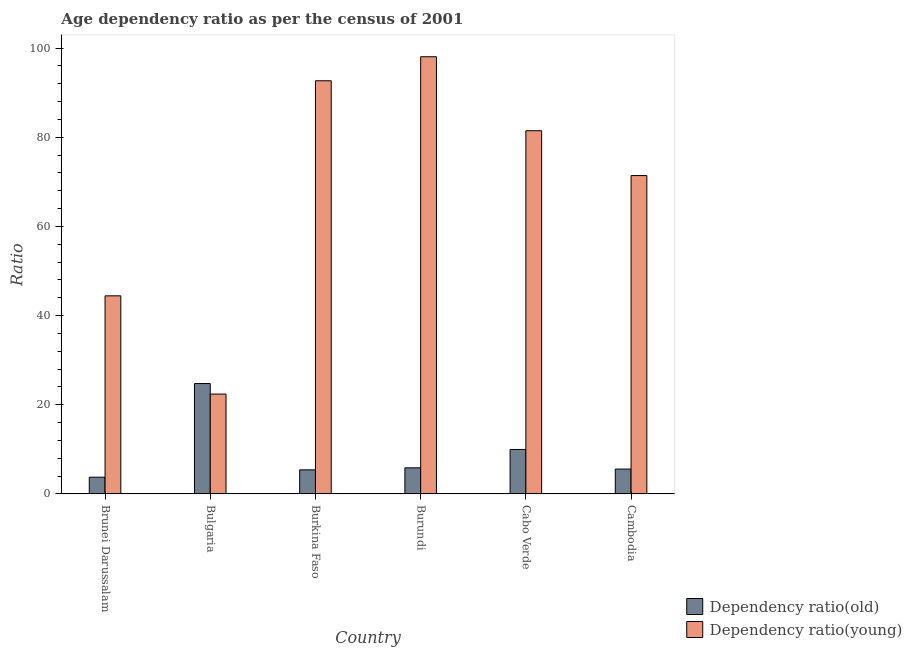How many bars are there on the 2nd tick from the left?
Your answer should be compact. 2. What is the label of the 2nd group of bars from the left?
Keep it short and to the point. Bulgaria. In how many cases, is the number of bars for a given country not equal to the number of legend labels?
Offer a terse response. 0. What is the age dependency ratio(young) in Brunei Darussalam?
Offer a terse response. 44.43. Across all countries, what is the maximum age dependency ratio(young)?
Offer a terse response. 98.06. Across all countries, what is the minimum age dependency ratio(old)?
Provide a succinct answer. 3.76. In which country was the age dependency ratio(young) maximum?
Give a very brief answer. Burundi. In which country was the age dependency ratio(old) minimum?
Keep it short and to the point. Brunei Darussalam. What is the total age dependency ratio(young) in the graph?
Ensure brevity in your answer.  410.42. What is the difference between the age dependency ratio(young) in Brunei Darussalam and that in Cambodia?
Provide a short and direct response. -26.97. What is the difference between the age dependency ratio(young) in Bulgaria and the age dependency ratio(old) in Cabo Verde?
Offer a terse response. 12.42. What is the average age dependency ratio(young) per country?
Make the answer very short. 68.4. What is the difference between the age dependency ratio(old) and age dependency ratio(young) in Brunei Darussalam?
Your answer should be compact. -40.67. In how many countries, is the age dependency ratio(old) greater than 12 ?
Provide a succinct answer. 1. What is the ratio of the age dependency ratio(young) in Brunei Darussalam to that in Cambodia?
Keep it short and to the point. 0.62. Is the age dependency ratio(young) in Burundi less than that in Cambodia?
Your response must be concise. No. What is the difference between the highest and the second highest age dependency ratio(old)?
Your answer should be very brief. 14.79. What is the difference between the highest and the lowest age dependency ratio(young)?
Your response must be concise. 75.65. In how many countries, is the age dependency ratio(old) greater than the average age dependency ratio(old) taken over all countries?
Keep it short and to the point. 2. Is the sum of the age dependency ratio(young) in Burkina Faso and Burundi greater than the maximum age dependency ratio(old) across all countries?
Your answer should be compact. Yes. What does the 1st bar from the left in Bulgaria represents?
Provide a succinct answer. Dependency ratio(old). What does the 2nd bar from the right in Brunei Darussalam represents?
Your answer should be compact. Dependency ratio(old). How many bars are there?
Your answer should be very brief. 12. What is the difference between two consecutive major ticks on the Y-axis?
Offer a terse response. 20. Are the values on the major ticks of Y-axis written in scientific E-notation?
Provide a succinct answer. No. Where does the legend appear in the graph?
Provide a short and direct response. Bottom right. What is the title of the graph?
Your answer should be very brief. Age dependency ratio as per the census of 2001. Does "National Visitors" appear as one of the legend labels in the graph?
Offer a very short reply. No. What is the label or title of the X-axis?
Offer a terse response. Country. What is the label or title of the Y-axis?
Your response must be concise. Ratio. What is the Ratio in Dependency ratio(old) in Brunei Darussalam?
Your answer should be very brief. 3.76. What is the Ratio in Dependency ratio(young) in Brunei Darussalam?
Provide a short and direct response. 44.43. What is the Ratio in Dependency ratio(old) in Bulgaria?
Give a very brief answer. 24.77. What is the Ratio of Dependency ratio(young) in Bulgaria?
Ensure brevity in your answer.  22.4. What is the Ratio of Dependency ratio(old) in Burkina Faso?
Provide a short and direct response. 5.41. What is the Ratio in Dependency ratio(young) in Burkina Faso?
Your answer should be very brief. 92.66. What is the Ratio in Dependency ratio(old) in Burundi?
Provide a succinct answer. 5.86. What is the Ratio in Dependency ratio(young) in Burundi?
Your answer should be compact. 98.06. What is the Ratio of Dependency ratio(old) in Cabo Verde?
Ensure brevity in your answer.  9.98. What is the Ratio of Dependency ratio(young) in Cabo Verde?
Offer a terse response. 81.46. What is the Ratio of Dependency ratio(old) in Cambodia?
Provide a short and direct response. 5.58. What is the Ratio in Dependency ratio(young) in Cambodia?
Give a very brief answer. 71.41. Across all countries, what is the maximum Ratio of Dependency ratio(old)?
Provide a succinct answer. 24.77. Across all countries, what is the maximum Ratio in Dependency ratio(young)?
Ensure brevity in your answer.  98.06. Across all countries, what is the minimum Ratio of Dependency ratio(old)?
Provide a short and direct response. 3.76. Across all countries, what is the minimum Ratio in Dependency ratio(young)?
Ensure brevity in your answer.  22.4. What is the total Ratio in Dependency ratio(old) in the graph?
Your answer should be compact. 55.36. What is the total Ratio of Dependency ratio(young) in the graph?
Keep it short and to the point. 410.42. What is the difference between the Ratio in Dependency ratio(old) in Brunei Darussalam and that in Bulgaria?
Your answer should be compact. -21. What is the difference between the Ratio in Dependency ratio(young) in Brunei Darussalam and that in Bulgaria?
Provide a short and direct response. 22.03. What is the difference between the Ratio in Dependency ratio(old) in Brunei Darussalam and that in Burkina Faso?
Ensure brevity in your answer.  -1.65. What is the difference between the Ratio of Dependency ratio(young) in Brunei Darussalam and that in Burkina Faso?
Make the answer very short. -48.23. What is the difference between the Ratio of Dependency ratio(old) in Brunei Darussalam and that in Burundi?
Ensure brevity in your answer.  -2.1. What is the difference between the Ratio in Dependency ratio(young) in Brunei Darussalam and that in Burundi?
Your response must be concise. -53.62. What is the difference between the Ratio in Dependency ratio(old) in Brunei Darussalam and that in Cabo Verde?
Make the answer very short. -6.22. What is the difference between the Ratio in Dependency ratio(young) in Brunei Darussalam and that in Cabo Verde?
Make the answer very short. -37.03. What is the difference between the Ratio in Dependency ratio(old) in Brunei Darussalam and that in Cambodia?
Provide a short and direct response. -1.82. What is the difference between the Ratio of Dependency ratio(young) in Brunei Darussalam and that in Cambodia?
Ensure brevity in your answer.  -26.97. What is the difference between the Ratio in Dependency ratio(old) in Bulgaria and that in Burkina Faso?
Keep it short and to the point. 19.36. What is the difference between the Ratio of Dependency ratio(young) in Bulgaria and that in Burkina Faso?
Your answer should be compact. -70.26. What is the difference between the Ratio in Dependency ratio(old) in Bulgaria and that in Burundi?
Ensure brevity in your answer.  18.91. What is the difference between the Ratio of Dependency ratio(young) in Bulgaria and that in Burundi?
Provide a short and direct response. -75.65. What is the difference between the Ratio in Dependency ratio(old) in Bulgaria and that in Cabo Verde?
Provide a short and direct response. 14.79. What is the difference between the Ratio in Dependency ratio(young) in Bulgaria and that in Cabo Verde?
Offer a very short reply. -59.06. What is the difference between the Ratio in Dependency ratio(old) in Bulgaria and that in Cambodia?
Give a very brief answer. 19.18. What is the difference between the Ratio in Dependency ratio(young) in Bulgaria and that in Cambodia?
Your answer should be compact. -49. What is the difference between the Ratio in Dependency ratio(old) in Burkina Faso and that in Burundi?
Make the answer very short. -0.45. What is the difference between the Ratio in Dependency ratio(young) in Burkina Faso and that in Burundi?
Provide a succinct answer. -5.39. What is the difference between the Ratio of Dependency ratio(old) in Burkina Faso and that in Cabo Verde?
Provide a succinct answer. -4.57. What is the difference between the Ratio of Dependency ratio(young) in Burkina Faso and that in Cabo Verde?
Provide a short and direct response. 11.2. What is the difference between the Ratio of Dependency ratio(old) in Burkina Faso and that in Cambodia?
Give a very brief answer. -0.17. What is the difference between the Ratio in Dependency ratio(young) in Burkina Faso and that in Cambodia?
Offer a very short reply. 21.26. What is the difference between the Ratio of Dependency ratio(old) in Burundi and that in Cabo Verde?
Offer a very short reply. -4.12. What is the difference between the Ratio in Dependency ratio(young) in Burundi and that in Cabo Verde?
Keep it short and to the point. 16.59. What is the difference between the Ratio in Dependency ratio(old) in Burundi and that in Cambodia?
Offer a very short reply. 0.28. What is the difference between the Ratio of Dependency ratio(young) in Burundi and that in Cambodia?
Keep it short and to the point. 26.65. What is the difference between the Ratio of Dependency ratio(old) in Cabo Verde and that in Cambodia?
Ensure brevity in your answer.  4.4. What is the difference between the Ratio in Dependency ratio(young) in Cabo Verde and that in Cambodia?
Ensure brevity in your answer.  10.05. What is the difference between the Ratio in Dependency ratio(old) in Brunei Darussalam and the Ratio in Dependency ratio(young) in Bulgaria?
Ensure brevity in your answer.  -18.64. What is the difference between the Ratio in Dependency ratio(old) in Brunei Darussalam and the Ratio in Dependency ratio(young) in Burkina Faso?
Make the answer very short. -88.9. What is the difference between the Ratio of Dependency ratio(old) in Brunei Darussalam and the Ratio of Dependency ratio(young) in Burundi?
Offer a terse response. -94.29. What is the difference between the Ratio in Dependency ratio(old) in Brunei Darussalam and the Ratio in Dependency ratio(young) in Cabo Verde?
Your response must be concise. -77.7. What is the difference between the Ratio in Dependency ratio(old) in Brunei Darussalam and the Ratio in Dependency ratio(young) in Cambodia?
Ensure brevity in your answer.  -67.64. What is the difference between the Ratio of Dependency ratio(old) in Bulgaria and the Ratio of Dependency ratio(young) in Burkina Faso?
Provide a short and direct response. -67.9. What is the difference between the Ratio in Dependency ratio(old) in Bulgaria and the Ratio in Dependency ratio(young) in Burundi?
Keep it short and to the point. -73.29. What is the difference between the Ratio in Dependency ratio(old) in Bulgaria and the Ratio in Dependency ratio(young) in Cabo Verde?
Offer a very short reply. -56.69. What is the difference between the Ratio in Dependency ratio(old) in Bulgaria and the Ratio in Dependency ratio(young) in Cambodia?
Provide a short and direct response. -46.64. What is the difference between the Ratio of Dependency ratio(old) in Burkina Faso and the Ratio of Dependency ratio(young) in Burundi?
Your answer should be very brief. -92.65. What is the difference between the Ratio in Dependency ratio(old) in Burkina Faso and the Ratio in Dependency ratio(young) in Cabo Verde?
Give a very brief answer. -76.05. What is the difference between the Ratio of Dependency ratio(old) in Burkina Faso and the Ratio of Dependency ratio(young) in Cambodia?
Ensure brevity in your answer.  -66. What is the difference between the Ratio in Dependency ratio(old) in Burundi and the Ratio in Dependency ratio(young) in Cabo Verde?
Provide a succinct answer. -75.6. What is the difference between the Ratio of Dependency ratio(old) in Burundi and the Ratio of Dependency ratio(young) in Cambodia?
Provide a succinct answer. -65.55. What is the difference between the Ratio in Dependency ratio(old) in Cabo Verde and the Ratio in Dependency ratio(young) in Cambodia?
Ensure brevity in your answer.  -61.43. What is the average Ratio of Dependency ratio(old) per country?
Your response must be concise. 9.23. What is the average Ratio of Dependency ratio(young) per country?
Your response must be concise. 68.4. What is the difference between the Ratio of Dependency ratio(old) and Ratio of Dependency ratio(young) in Brunei Darussalam?
Give a very brief answer. -40.67. What is the difference between the Ratio of Dependency ratio(old) and Ratio of Dependency ratio(young) in Bulgaria?
Offer a terse response. 2.36. What is the difference between the Ratio in Dependency ratio(old) and Ratio in Dependency ratio(young) in Burkina Faso?
Provide a succinct answer. -87.25. What is the difference between the Ratio in Dependency ratio(old) and Ratio in Dependency ratio(young) in Burundi?
Keep it short and to the point. -92.2. What is the difference between the Ratio of Dependency ratio(old) and Ratio of Dependency ratio(young) in Cabo Verde?
Your answer should be very brief. -71.48. What is the difference between the Ratio in Dependency ratio(old) and Ratio in Dependency ratio(young) in Cambodia?
Your response must be concise. -65.82. What is the ratio of the Ratio of Dependency ratio(old) in Brunei Darussalam to that in Bulgaria?
Offer a very short reply. 0.15. What is the ratio of the Ratio of Dependency ratio(young) in Brunei Darussalam to that in Bulgaria?
Your answer should be compact. 1.98. What is the ratio of the Ratio of Dependency ratio(old) in Brunei Darussalam to that in Burkina Faso?
Your answer should be compact. 0.7. What is the ratio of the Ratio in Dependency ratio(young) in Brunei Darussalam to that in Burkina Faso?
Your answer should be very brief. 0.48. What is the ratio of the Ratio in Dependency ratio(old) in Brunei Darussalam to that in Burundi?
Make the answer very short. 0.64. What is the ratio of the Ratio of Dependency ratio(young) in Brunei Darussalam to that in Burundi?
Your response must be concise. 0.45. What is the ratio of the Ratio in Dependency ratio(old) in Brunei Darussalam to that in Cabo Verde?
Give a very brief answer. 0.38. What is the ratio of the Ratio of Dependency ratio(young) in Brunei Darussalam to that in Cabo Verde?
Offer a very short reply. 0.55. What is the ratio of the Ratio of Dependency ratio(old) in Brunei Darussalam to that in Cambodia?
Give a very brief answer. 0.67. What is the ratio of the Ratio of Dependency ratio(young) in Brunei Darussalam to that in Cambodia?
Offer a terse response. 0.62. What is the ratio of the Ratio of Dependency ratio(old) in Bulgaria to that in Burkina Faso?
Provide a short and direct response. 4.58. What is the ratio of the Ratio of Dependency ratio(young) in Bulgaria to that in Burkina Faso?
Your response must be concise. 0.24. What is the ratio of the Ratio in Dependency ratio(old) in Bulgaria to that in Burundi?
Provide a succinct answer. 4.23. What is the ratio of the Ratio of Dependency ratio(young) in Bulgaria to that in Burundi?
Your response must be concise. 0.23. What is the ratio of the Ratio in Dependency ratio(old) in Bulgaria to that in Cabo Verde?
Make the answer very short. 2.48. What is the ratio of the Ratio in Dependency ratio(young) in Bulgaria to that in Cabo Verde?
Make the answer very short. 0.28. What is the ratio of the Ratio in Dependency ratio(old) in Bulgaria to that in Cambodia?
Your answer should be compact. 4.44. What is the ratio of the Ratio of Dependency ratio(young) in Bulgaria to that in Cambodia?
Your response must be concise. 0.31. What is the ratio of the Ratio in Dependency ratio(young) in Burkina Faso to that in Burundi?
Offer a terse response. 0.94. What is the ratio of the Ratio in Dependency ratio(old) in Burkina Faso to that in Cabo Verde?
Your response must be concise. 0.54. What is the ratio of the Ratio of Dependency ratio(young) in Burkina Faso to that in Cabo Verde?
Offer a very short reply. 1.14. What is the ratio of the Ratio of Dependency ratio(old) in Burkina Faso to that in Cambodia?
Your answer should be very brief. 0.97. What is the ratio of the Ratio of Dependency ratio(young) in Burkina Faso to that in Cambodia?
Give a very brief answer. 1.3. What is the ratio of the Ratio in Dependency ratio(old) in Burundi to that in Cabo Verde?
Give a very brief answer. 0.59. What is the ratio of the Ratio in Dependency ratio(young) in Burundi to that in Cabo Verde?
Make the answer very short. 1.2. What is the ratio of the Ratio of Dependency ratio(old) in Burundi to that in Cambodia?
Provide a succinct answer. 1.05. What is the ratio of the Ratio in Dependency ratio(young) in Burundi to that in Cambodia?
Your response must be concise. 1.37. What is the ratio of the Ratio in Dependency ratio(old) in Cabo Verde to that in Cambodia?
Your answer should be very brief. 1.79. What is the ratio of the Ratio in Dependency ratio(young) in Cabo Verde to that in Cambodia?
Offer a very short reply. 1.14. What is the difference between the highest and the second highest Ratio of Dependency ratio(old)?
Ensure brevity in your answer.  14.79. What is the difference between the highest and the second highest Ratio of Dependency ratio(young)?
Your response must be concise. 5.39. What is the difference between the highest and the lowest Ratio in Dependency ratio(old)?
Offer a very short reply. 21. What is the difference between the highest and the lowest Ratio in Dependency ratio(young)?
Your answer should be compact. 75.65. 